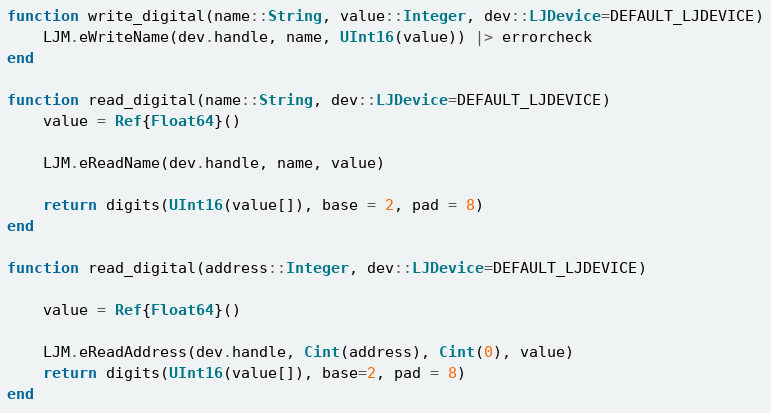Convert code to text. <code><loc_0><loc_0><loc_500><loc_500><_Julia_>function write_digital(name::String, value::Integer, dev::LJDevice=DEFAULT_LJDEVICE)
    LJM.eWriteName(dev.handle, name, UInt16(value)) |> errorcheck
end

function read_digital(name::String, dev::LJDevice=DEFAULT_LJDEVICE)
    value = Ref{Float64}()

    LJM.eReadName(dev.handle, name, value)

    return digits(UInt16(value[]), base = 2, pad = 8)
end

function read_digital(address::Integer, dev::LJDevice=DEFAULT_LJDEVICE)

    value = Ref{Float64}()

    LJM.eReadAddress(dev.handle, Cint(address), Cint(0), value) 
    return digits(UInt16(value[]), base=2, pad = 8)
end


</code> 